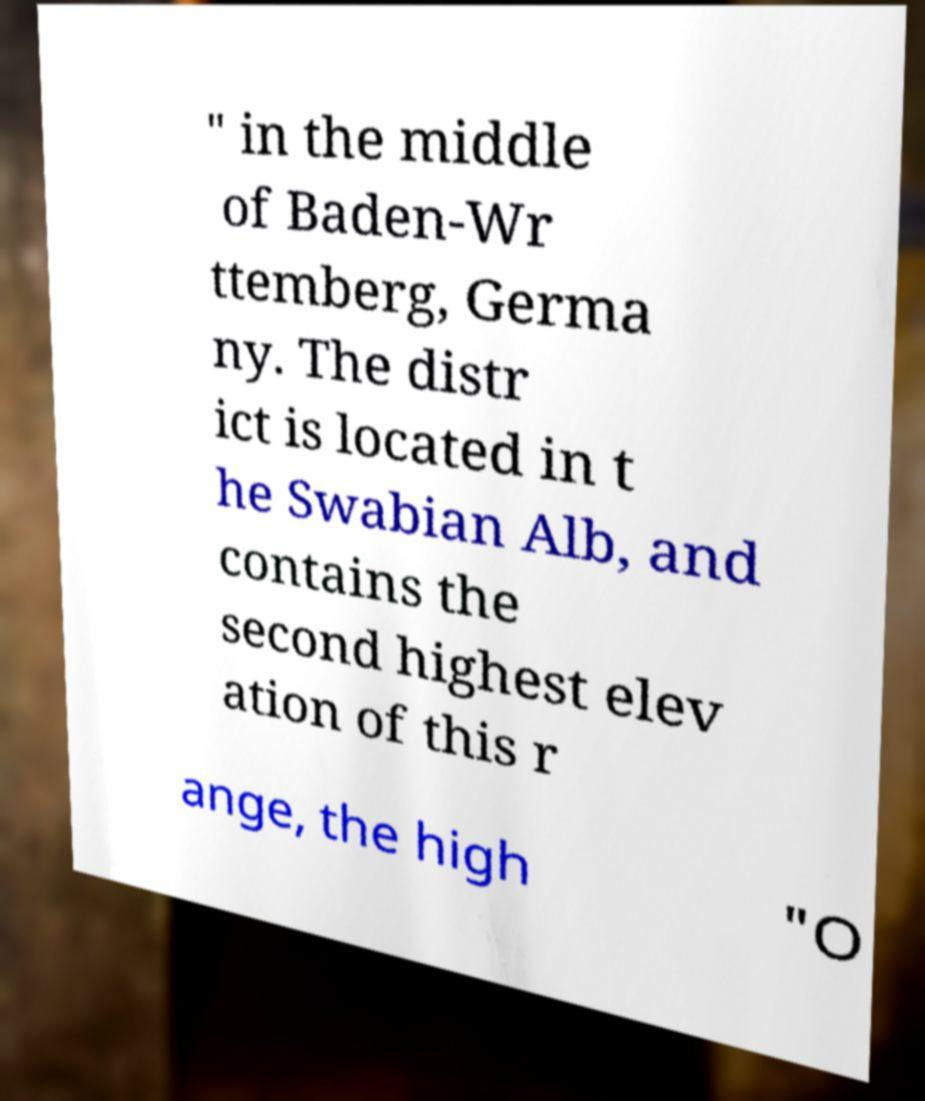Could you extract and type out the text from this image? " in the middle of Baden-Wr ttemberg, Germa ny. The distr ict is located in t he Swabian Alb, and contains the second highest elev ation of this r ange, the high "O 